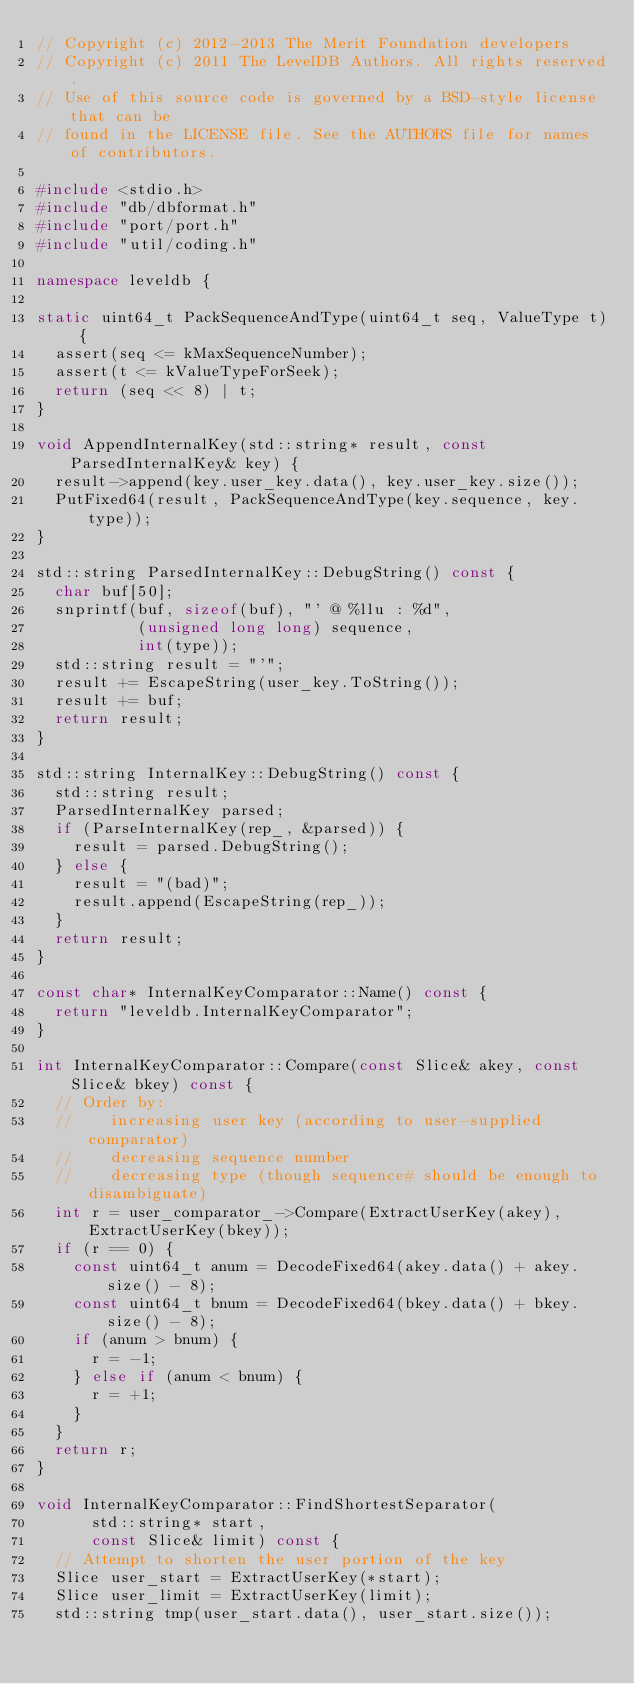<code> <loc_0><loc_0><loc_500><loc_500><_C++_>// Copyright (c) 2012-2013 The Merit Foundation developers
// Copyright (c) 2011 The LevelDB Authors. All rights reserved.
// Use of this source code is governed by a BSD-style license that can be
// found in the LICENSE file. See the AUTHORS file for names of contributors.

#include <stdio.h>
#include "db/dbformat.h"
#include "port/port.h"
#include "util/coding.h"

namespace leveldb {

static uint64_t PackSequenceAndType(uint64_t seq, ValueType t) {
  assert(seq <= kMaxSequenceNumber);
  assert(t <= kValueTypeForSeek);
  return (seq << 8) | t;
}

void AppendInternalKey(std::string* result, const ParsedInternalKey& key) {
  result->append(key.user_key.data(), key.user_key.size());
  PutFixed64(result, PackSequenceAndType(key.sequence, key.type));
}

std::string ParsedInternalKey::DebugString() const {
  char buf[50];
  snprintf(buf, sizeof(buf), "' @ %llu : %d",
           (unsigned long long) sequence,
           int(type));
  std::string result = "'";
  result += EscapeString(user_key.ToString());
  result += buf;
  return result;
}

std::string InternalKey::DebugString() const {
  std::string result;
  ParsedInternalKey parsed;
  if (ParseInternalKey(rep_, &parsed)) {
    result = parsed.DebugString();
  } else {
    result = "(bad)";
    result.append(EscapeString(rep_));
  }
  return result;
}

const char* InternalKeyComparator::Name() const {
  return "leveldb.InternalKeyComparator";
}

int InternalKeyComparator::Compare(const Slice& akey, const Slice& bkey) const {
  // Order by:
  //    increasing user key (according to user-supplied comparator)
  //    decreasing sequence number
  //    decreasing type (though sequence# should be enough to disambiguate)
  int r = user_comparator_->Compare(ExtractUserKey(akey), ExtractUserKey(bkey));
  if (r == 0) {
    const uint64_t anum = DecodeFixed64(akey.data() + akey.size() - 8);
    const uint64_t bnum = DecodeFixed64(bkey.data() + bkey.size() - 8);
    if (anum > bnum) {
      r = -1;
    } else if (anum < bnum) {
      r = +1;
    }
  }
  return r;
}

void InternalKeyComparator::FindShortestSeparator(
      std::string* start,
      const Slice& limit) const {
  // Attempt to shorten the user portion of the key
  Slice user_start = ExtractUserKey(*start);
  Slice user_limit = ExtractUserKey(limit);
  std::string tmp(user_start.data(), user_start.size());</code> 